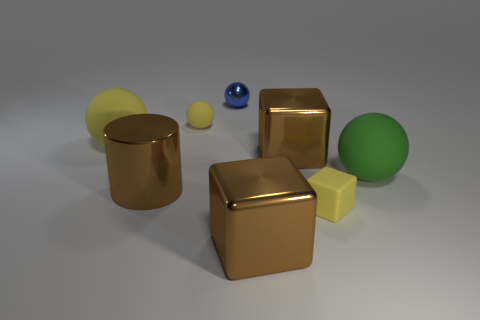Subtract all rubber spheres. How many spheres are left? 1 Add 2 large brown shiny cylinders. How many objects exist? 10 Subtract all gray spheres. How many brown blocks are left? 2 Subtract all green spheres. How many spheres are left? 3 Subtract 1 blocks. How many blocks are left? 2 Subtract all red blocks. Subtract all purple cylinders. How many blocks are left? 3 Add 5 large yellow rubber things. How many large yellow rubber things are left? 6 Add 6 brown metallic cylinders. How many brown metallic cylinders exist? 7 Subtract 0 blue cubes. How many objects are left? 8 Subtract all blocks. How many objects are left? 5 